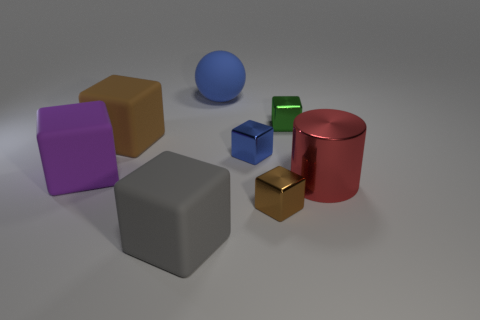Subtract all green balls. How many brown cubes are left? 2 Subtract all purple cubes. How many cubes are left? 5 Subtract 3 blocks. How many blocks are left? 3 Subtract all green cubes. How many cubes are left? 5 Add 1 blue metal objects. How many objects exist? 9 Subtract all gray blocks. Subtract all green cylinders. How many blocks are left? 5 Subtract all cylinders. How many objects are left? 7 Subtract all large cylinders. Subtract all tiny cyan metal cylinders. How many objects are left? 7 Add 8 big red metal cylinders. How many big red metal cylinders are left? 9 Add 1 gray matte cubes. How many gray matte cubes exist? 2 